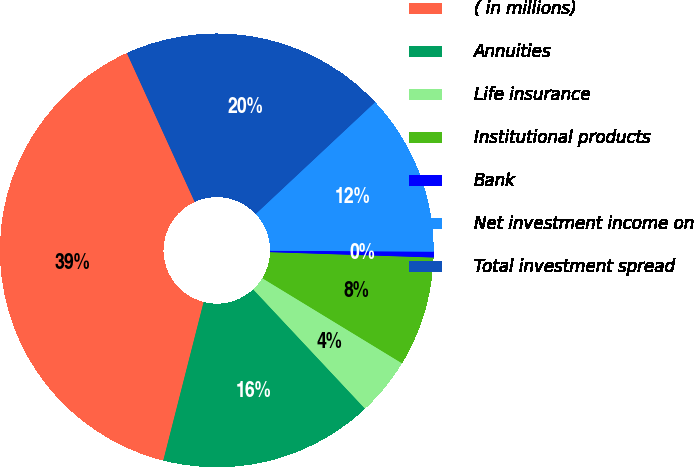<chart> <loc_0><loc_0><loc_500><loc_500><pie_chart><fcel>( in millions)<fcel>Annuities<fcel>Life insurance<fcel>Institutional products<fcel>Bank<fcel>Net investment income on<fcel>Total investment spread<nl><fcel>39.23%<fcel>15.95%<fcel>4.31%<fcel>8.19%<fcel>0.43%<fcel>12.07%<fcel>19.83%<nl></chart> 